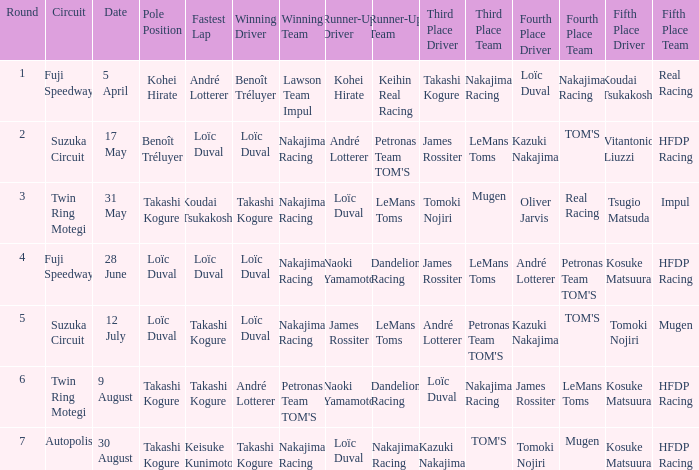Who has the fastest lap where Benoît Tréluyer got the pole position? Loïc Duval. Give me the full table as a dictionary. {'header': ['Round', 'Circuit', 'Date', 'Pole Position', 'Fastest Lap', 'Winning Driver', 'Winning Team', 'Runner-Up Driver', 'Runner-Up Team', 'Third Place Driver', 'Third Place Team', 'Fourth Place Driver', 'Fourth Place Team', 'Fifth Place Driver', 'Fifth Place Team '], 'rows': [['1', 'Fuji Speedway', '5 April', 'Kohei Hirate', 'André Lotterer', 'Benoît Tréluyer', 'Lawson Team Impul', 'Kohei Hirate', 'Keihin Real Racing', 'Takashi Kogure', 'Nakajima Racing', 'Loïc Duval', 'Nakajima Racing', 'Koudai Tsukakoshi', 'Real Racing'], ['2', 'Suzuka Circuit', '17 May', 'Benoît Tréluyer', 'Loïc Duval', 'Loïc Duval', 'Nakajima Racing', 'André Lotterer', "Petronas Team TOM'S", 'James Rossiter', 'LeMans Toms', 'Kazuki Nakajima', "TOM'S", 'Vitantonio Liuzzi', 'HFDP Racing  '], ['3', 'Twin Ring Motegi', '31 May', 'Takashi Kogure', 'Koudai Tsukakoshi', 'Takashi Kogure', 'Nakajima Racing', 'Loïc Duval', 'LeMans Toms', 'Tomoki Nojiri', 'Mugen', 'Oliver Jarvis', 'Real Racing', 'Tsugio Matsuda', 'Impul     '], ['4', 'Fuji Speedway', '28 June', 'Loïc Duval', 'Loïc Duval', 'Loïc Duval', 'Nakajima Racing', 'Naoki Yamamoto', 'Dandelion Racing', 'James Rossiter', 'LeMans Toms', 'André Lotterer', "Petronas Team TOM'S", 'Kosuke Matsuura', 'HFDP Racing     '], ['5', 'Suzuka Circuit', '12 July', 'Loïc Duval', 'Takashi Kogure', 'Loïc Duval', 'Nakajima Racing', 'James Rossiter', 'LeMans Toms', 'André Lotterer', "Petronas Team TOM'S", 'Kazuki Nakajima', "TOM'S", 'Tomoki Nojiri', 'Mugen     '], ['6', 'Twin Ring Motegi', '9 August', 'Takashi Kogure', 'Takashi Kogure', 'André Lotterer', "Petronas Team TOM'S", 'Naoki Yamamoto', 'Dandelion Racing', 'Loïc Duval', 'Nakajima Racing', 'James Rossiter', 'LeMans Toms', 'Kosuke Matsuura', 'HFDP Racing   '], ['7', 'Autopolis', '30 August', 'Takashi Kogure', 'Keisuke Kunimoto', 'Takashi Kogure', 'Nakajima Racing', 'Loïc Duval', 'Nakajima Racing', 'Kazuki Nakajima', "TOM'S", 'Tomoki Nojiri', 'Mugen', 'Kosuke Matsuura', 'HFDP Racing']]} 